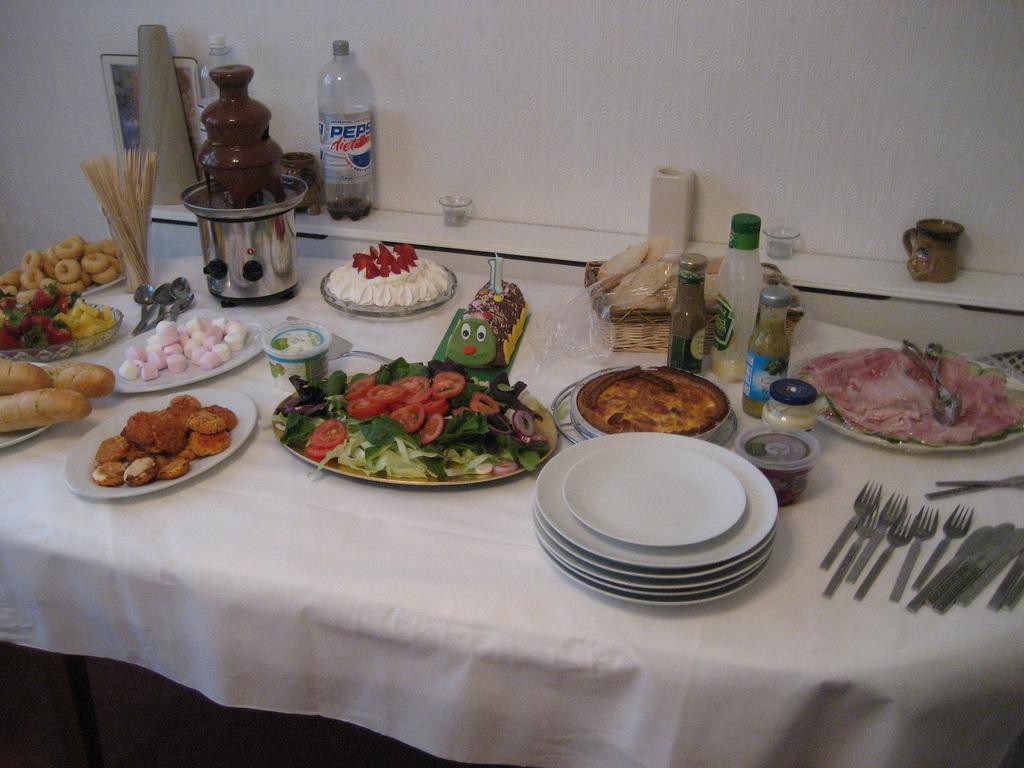In one or two sentences, can you explain what this image depicts? In this image we can see plates with food, forks, knives, bottles and cans on the table. 